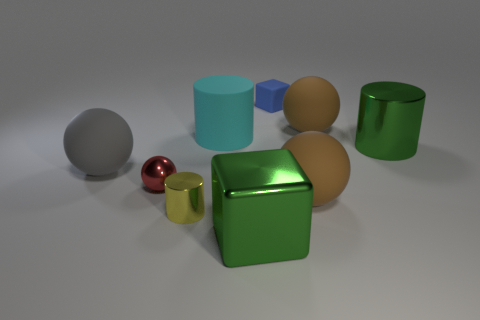Are all the objects solid, or do some have openings? From the visible perspectives, all the objects seem to be solid. None of the objects in the image show any visible openings or holes. 